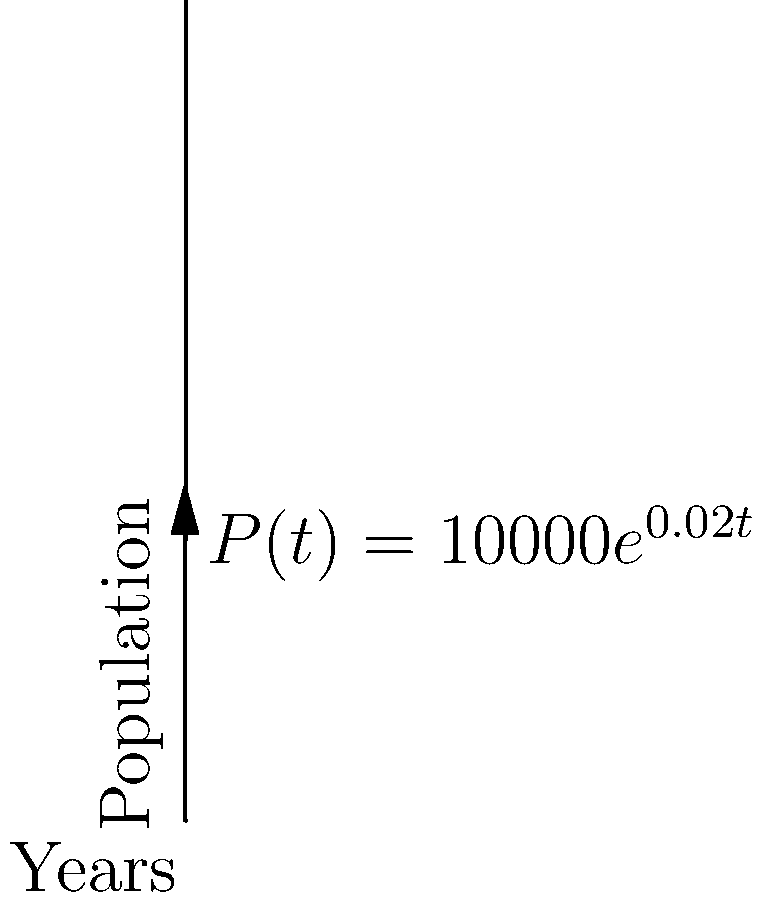The population of a medieval kingdom is modeled by the function $P(t) = 10000e^{0.02t}$, where $P(t)$ represents the population after $t$ years. Using this model, determine the rate at which the population is growing after 50 years. Express your answer in people per year, rounded to the nearest whole number. To solve this problem, we'll follow these steps:

1) The rate of population growth is given by the derivative of the population function. So, we need to find $P'(t)$.

2) To find $P'(t)$, we use the chain rule:
   $P'(t) = 10000 \cdot 0.02 \cdot e^{0.02t}$
   $P'(t) = 200e^{0.02t}$

3) Now, we need to evaluate this at $t = 50$:
   $P'(50) = 200e^{0.02 \cdot 50}$
   $P'(50) = 200e^1$

4) Calculate this value:
   $P'(50) = 200 \cdot e \approx 200 \cdot 2.71828 \approx 543.656$

5) Rounding to the nearest whole number:
   $P'(50) \approx 544$

This means that after 50 years, the population is growing at a rate of approximately 544 people per year.
Answer: 544 people per year 